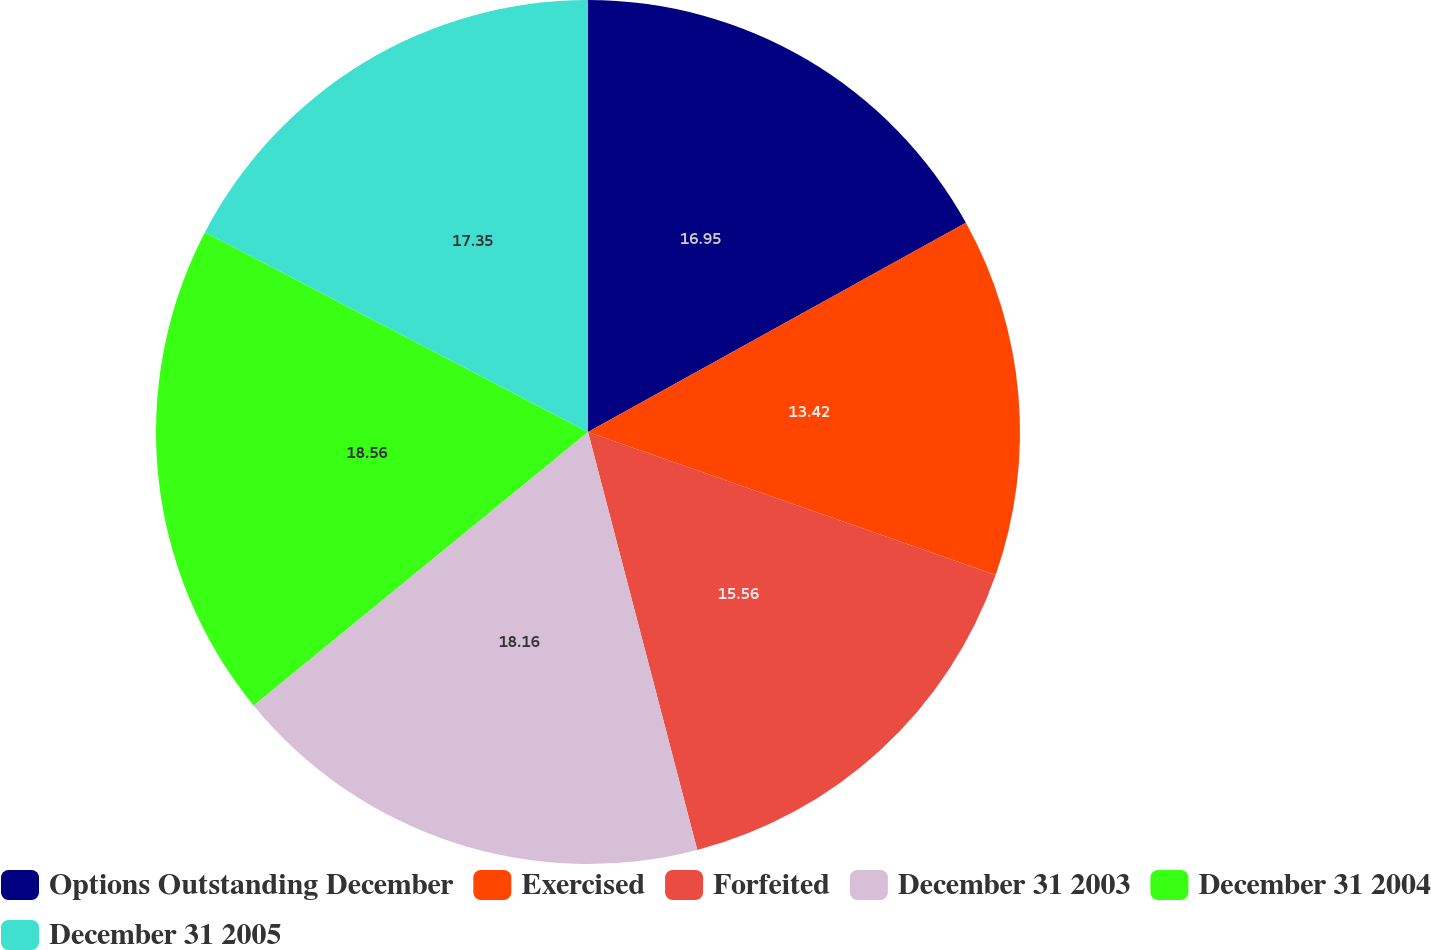Convert chart to OTSL. <chart><loc_0><loc_0><loc_500><loc_500><pie_chart><fcel>Options Outstanding December<fcel>Exercised<fcel>Forfeited<fcel>December 31 2003<fcel>December 31 2004<fcel>December 31 2005<nl><fcel>16.95%<fcel>13.42%<fcel>15.56%<fcel>18.16%<fcel>18.56%<fcel>17.35%<nl></chart> 